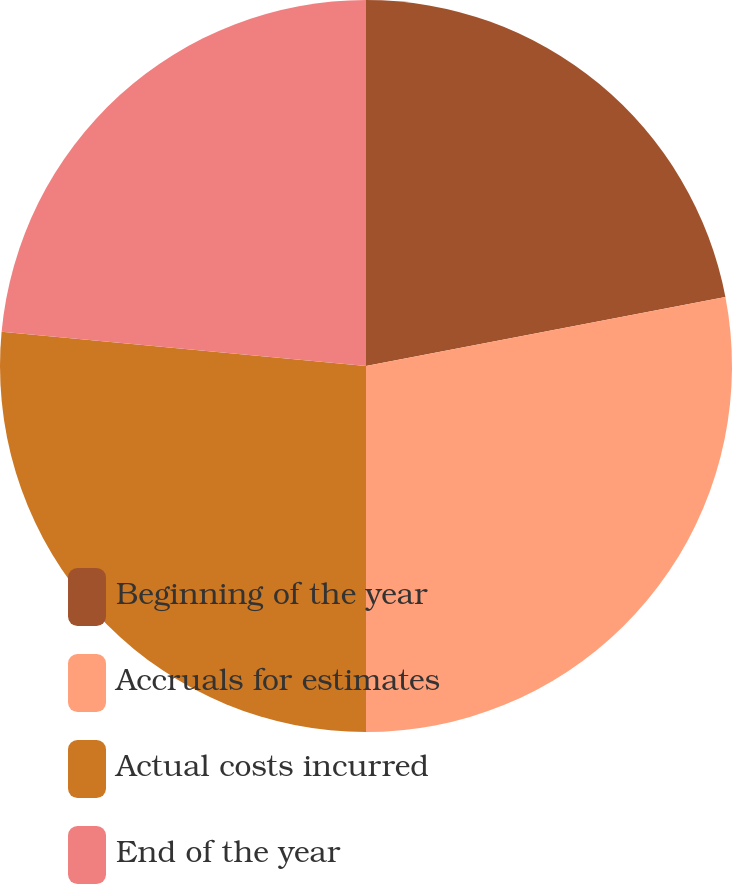Convert chart. <chart><loc_0><loc_0><loc_500><loc_500><pie_chart><fcel>Beginning of the year<fcel>Accruals for estimates<fcel>Actual costs incurred<fcel>End of the year<nl><fcel>21.98%<fcel>28.02%<fcel>26.49%<fcel>23.51%<nl></chart> 